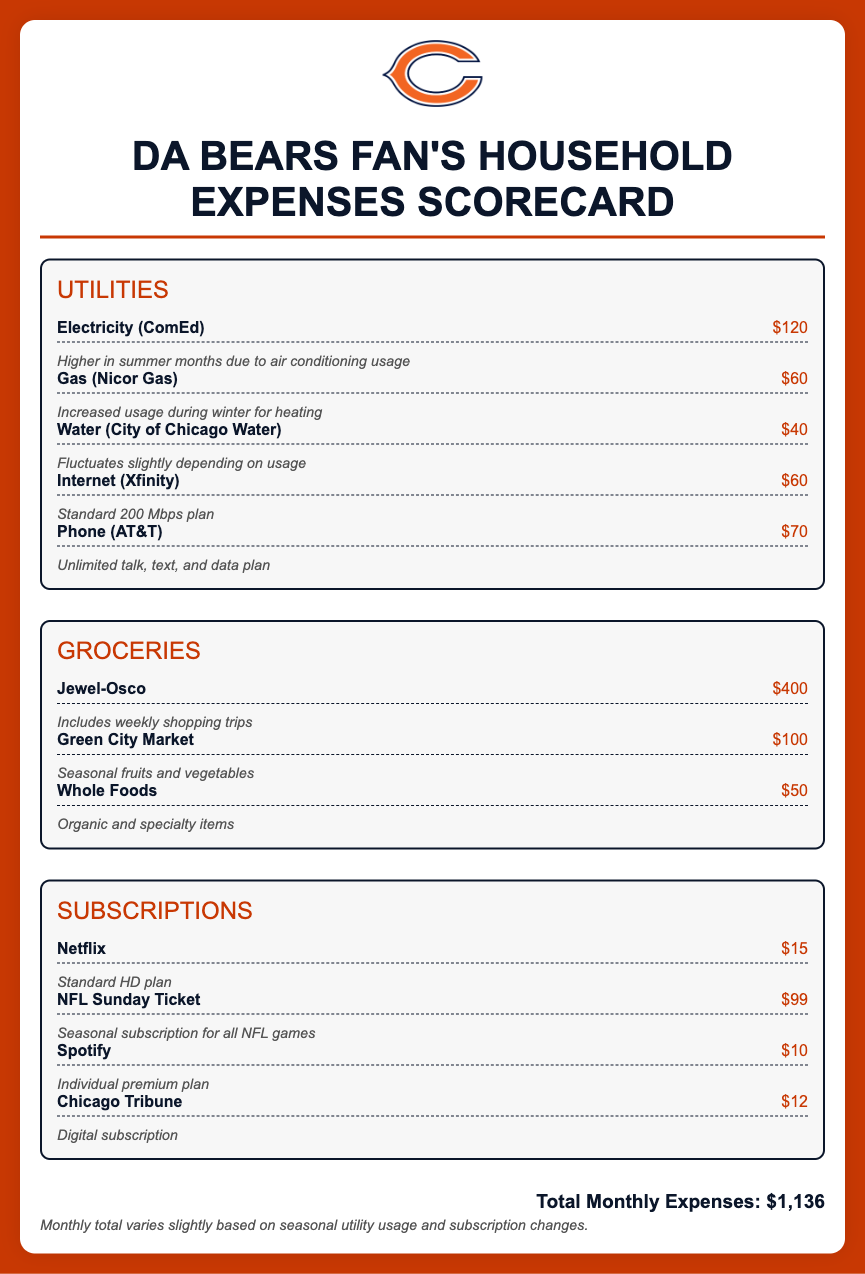What is the total monthly expense? The total monthly expense is provided at the end of the document, which takes into account all categories of expenses listed.
Answer: $1,136 What is the expense for electricity? The expense for electricity is explicitly mentioned under the utilities section as one of the cost items.
Answer: $120 How much is spent on groceries from Jewel-Osco? The amount spent on groceries at Jewel-Osco is clearly stated in the groceries section.
Answer: $400 What is the cost of the NFL Sunday Ticket subscription? The cost of the NFL Sunday Ticket is listed under the subscriptions section as one of the expenses.
Answer: $99 Which company provides the internet service? The document specifies the company providing internet service in the utilities section.
Answer: Xfinity How much is the gas bill? The monthly expense for gas is detailed in the utilities section, showing a specific amount.
Answer: $60 What type of plan is Netflix described as? The description of the Netflix plan is included in the subscriptions section, outlining its specific type.
Answer: Standard HD plan What is the monthly expense for the phone plan? The document states the expense associated with the phone service clearly in the utilities section.
Answer: $70 Which grocery store is mentioned for seasonal fruits and vegetables? The grocery store for seasonal items is identified in the groceries section of the scorecard.
Answer: Green City Market 